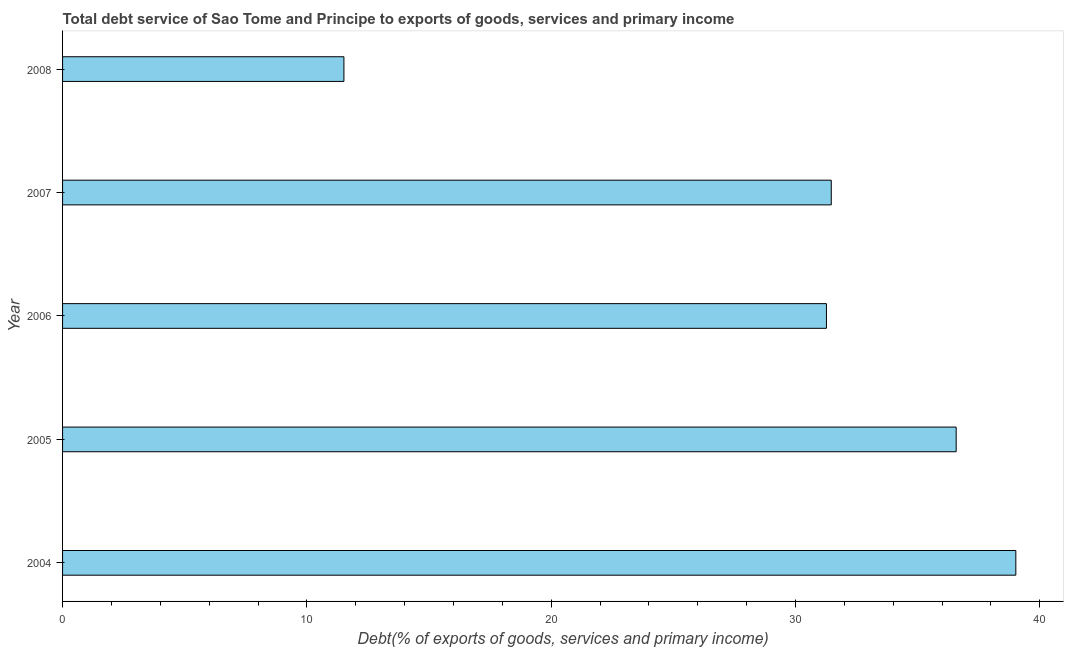What is the title of the graph?
Offer a very short reply. Total debt service of Sao Tome and Principe to exports of goods, services and primary income. What is the label or title of the X-axis?
Provide a succinct answer. Debt(% of exports of goods, services and primary income). What is the label or title of the Y-axis?
Provide a succinct answer. Year. What is the total debt service in 2006?
Offer a terse response. 31.27. Across all years, what is the maximum total debt service?
Offer a very short reply. 39.02. Across all years, what is the minimum total debt service?
Offer a terse response. 11.52. In which year was the total debt service minimum?
Offer a very short reply. 2008. What is the sum of the total debt service?
Offer a terse response. 149.86. What is the difference between the total debt service in 2004 and 2006?
Provide a short and direct response. 7.75. What is the average total debt service per year?
Ensure brevity in your answer.  29.97. What is the median total debt service?
Offer a terse response. 31.47. What is the ratio of the total debt service in 2007 to that in 2008?
Ensure brevity in your answer.  2.73. Is the total debt service in 2004 less than that in 2008?
Provide a succinct answer. No. Is the difference between the total debt service in 2006 and 2007 greater than the difference between any two years?
Keep it short and to the point. No. What is the difference between the highest and the second highest total debt service?
Ensure brevity in your answer.  2.44. Is the sum of the total debt service in 2005 and 2008 greater than the maximum total debt service across all years?
Your answer should be compact. Yes. Are all the bars in the graph horizontal?
Offer a terse response. Yes. How many years are there in the graph?
Make the answer very short. 5. What is the difference between two consecutive major ticks on the X-axis?
Your response must be concise. 10. What is the Debt(% of exports of goods, services and primary income) in 2004?
Offer a very short reply. 39.02. What is the Debt(% of exports of goods, services and primary income) of 2005?
Provide a succinct answer. 36.58. What is the Debt(% of exports of goods, services and primary income) in 2006?
Offer a very short reply. 31.27. What is the Debt(% of exports of goods, services and primary income) in 2007?
Offer a very short reply. 31.47. What is the Debt(% of exports of goods, services and primary income) of 2008?
Your answer should be compact. 11.52. What is the difference between the Debt(% of exports of goods, services and primary income) in 2004 and 2005?
Offer a terse response. 2.44. What is the difference between the Debt(% of exports of goods, services and primary income) in 2004 and 2006?
Offer a very short reply. 7.75. What is the difference between the Debt(% of exports of goods, services and primary income) in 2004 and 2007?
Offer a very short reply. 7.55. What is the difference between the Debt(% of exports of goods, services and primary income) in 2004 and 2008?
Make the answer very short. 27.5. What is the difference between the Debt(% of exports of goods, services and primary income) in 2005 and 2006?
Provide a succinct answer. 5.31. What is the difference between the Debt(% of exports of goods, services and primary income) in 2005 and 2007?
Your answer should be compact. 5.11. What is the difference between the Debt(% of exports of goods, services and primary income) in 2005 and 2008?
Your answer should be compact. 25.06. What is the difference between the Debt(% of exports of goods, services and primary income) in 2006 and 2007?
Your response must be concise. -0.2. What is the difference between the Debt(% of exports of goods, services and primary income) in 2006 and 2008?
Give a very brief answer. 19.75. What is the difference between the Debt(% of exports of goods, services and primary income) in 2007 and 2008?
Ensure brevity in your answer.  19.95. What is the ratio of the Debt(% of exports of goods, services and primary income) in 2004 to that in 2005?
Provide a short and direct response. 1.07. What is the ratio of the Debt(% of exports of goods, services and primary income) in 2004 to that in 2006?
Ensure brevity in your answer.  1.25. What is the ratio of the Debt(% of exports of goods, services and primary income) in 2004 to that in 2007?
Keep it short and to the point. 1.24. What is the ratio of the Debt(% of exports of goods, services and primary income) in 2004 to that in 2008?
Your answer should be very brief. 3.39. What is the ratio of the Debt(% of exports of goods, services and primary income) in 2005 to that in 2006?
Your response must be concise. 1.17. What is the ratio of the Debt(% of exports of goods, services and primary income) in 2005 to that in 2007?
Keep it short and to the point. 1.16. What is the ratio of the Debt(% of exports of goods, services and primary income) in 2005 to that in 2008?
Make the answer very short. 3.18. What is the ratio of the Debt(% of exports of goods, services and primary income) in 2006 to that in 2007?
Your answer should be very brief. 0.99. What is the ratio of the Debt(% of exports of goods, services and primary income) in 2006 to that in 2008?
Offer a terse response. 2.71. What is the ratio of the Debt(% of exports of goods, services and primary income) in 2007 to that in 2008?
Offer a very short reply. 2.73. 